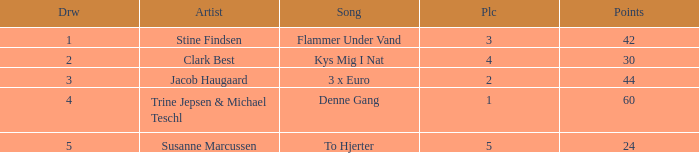What is the Draw that has Points larger than 44 and a Place larger than 1? None. 